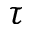Convert formula to latex. <formula><loc_0><loc_0><loc_500><loc_500>\tau</formula> 